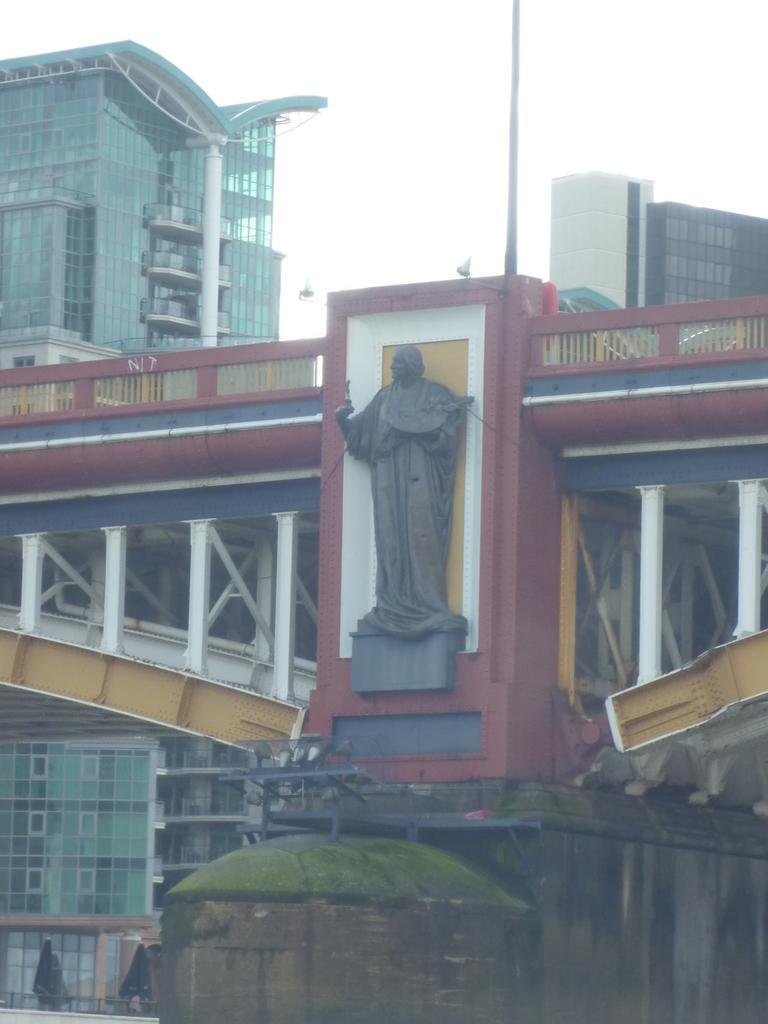Please provide a concise description of this image. This picture shows few buildings and we see a bridge and a statue and we see a cloudy sky. 